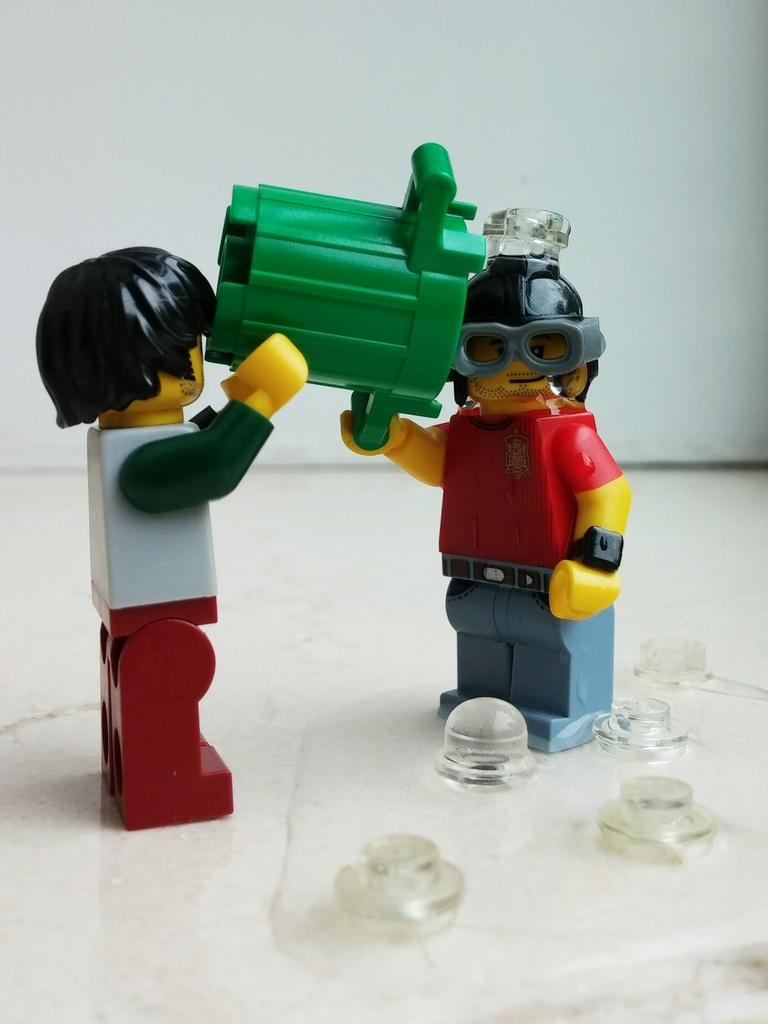What objects are present on the surface in the image? There are toys on a surface on a surface in the image. What can be seen in the background of the image? There is a wall in the background of the image. What type of grain is being used to build the wall in the image? There is no indication of the wall's construction material in the image, and no grain is visible. 